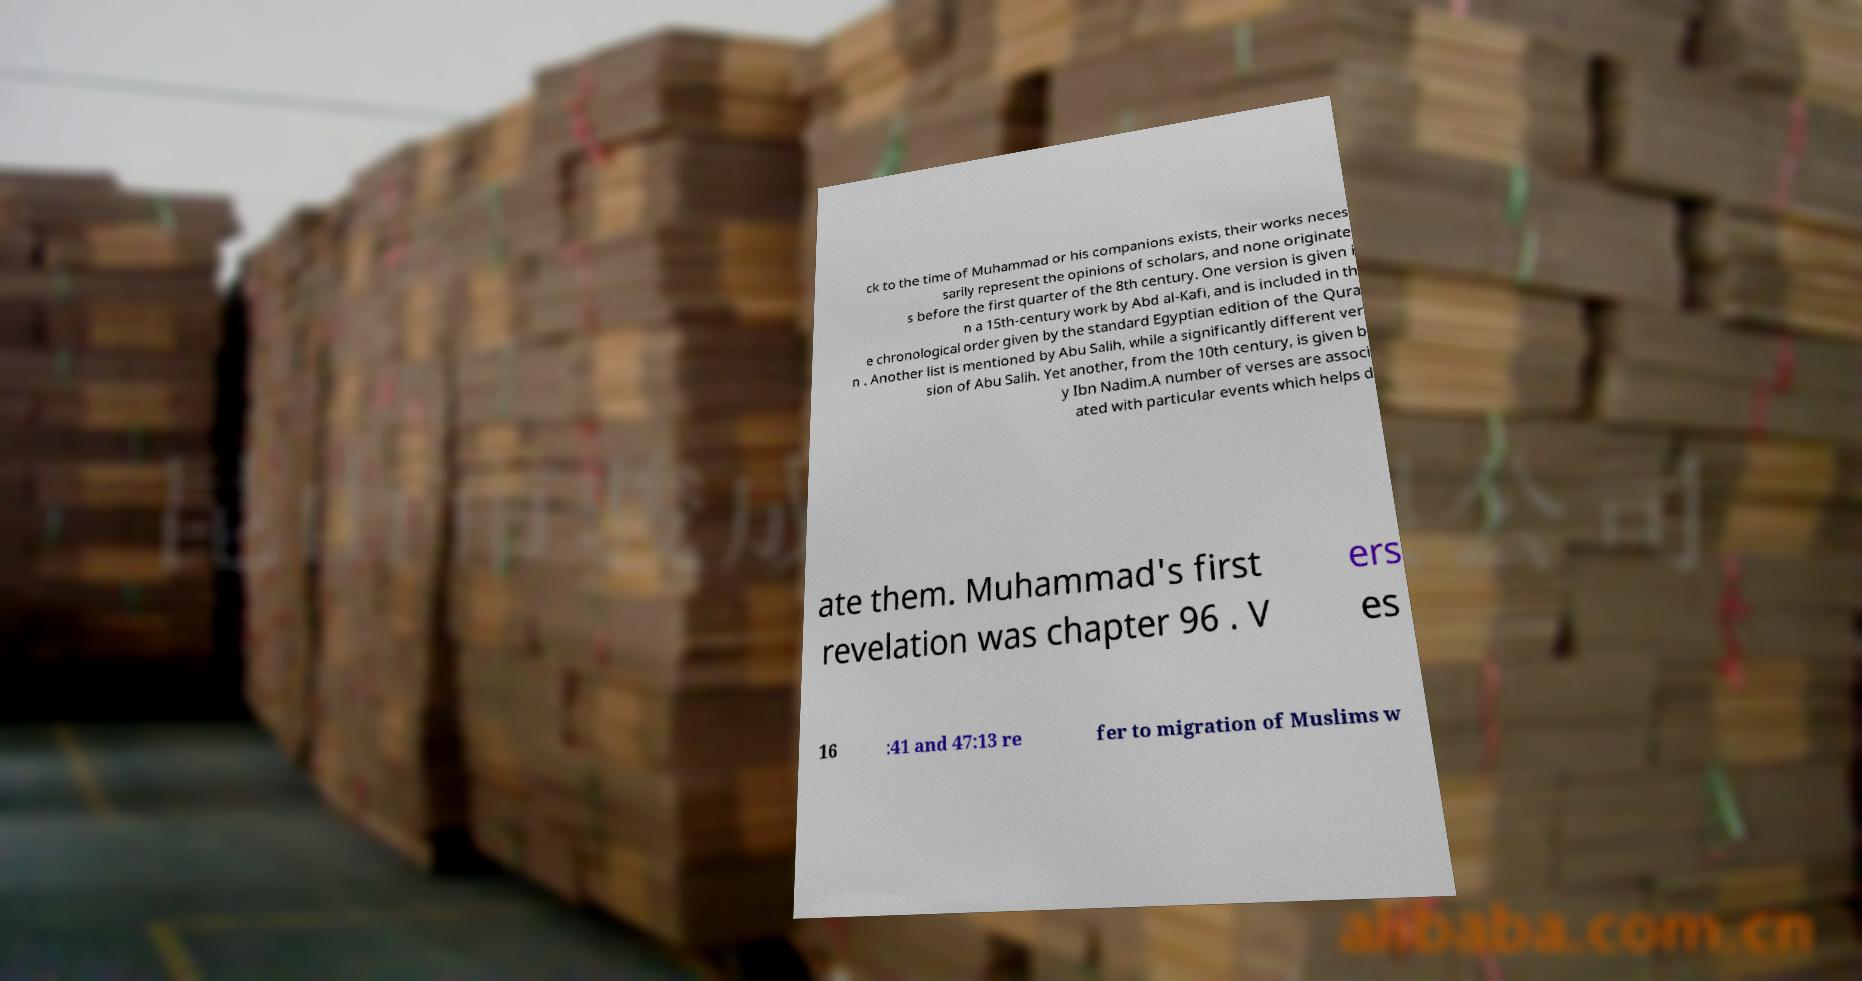Please read and relay the text visible in this image. What does it say? ck to the time of Muhammad or his companions exists, their works neces sarily represent the opinions of scholars, and none originate s before the first quarter of the 8th century. One version is given i n a 15th-century work by Abd al-Kafi, and is included in th e chronological order given by the standard Egyptian edition of the Qura n . Another list is mentioned by Abu Salih, while a significantly different ver sion of Abu Salih. Yet another, from the 10th century, is given b y Ibn Nadim.A number of verses are associ ated with particular events which helps d ate them. Muhammad's first revelation was chapter 96 . V ers es 16 :41 and 47:13 re fer to migration of Muslims w 